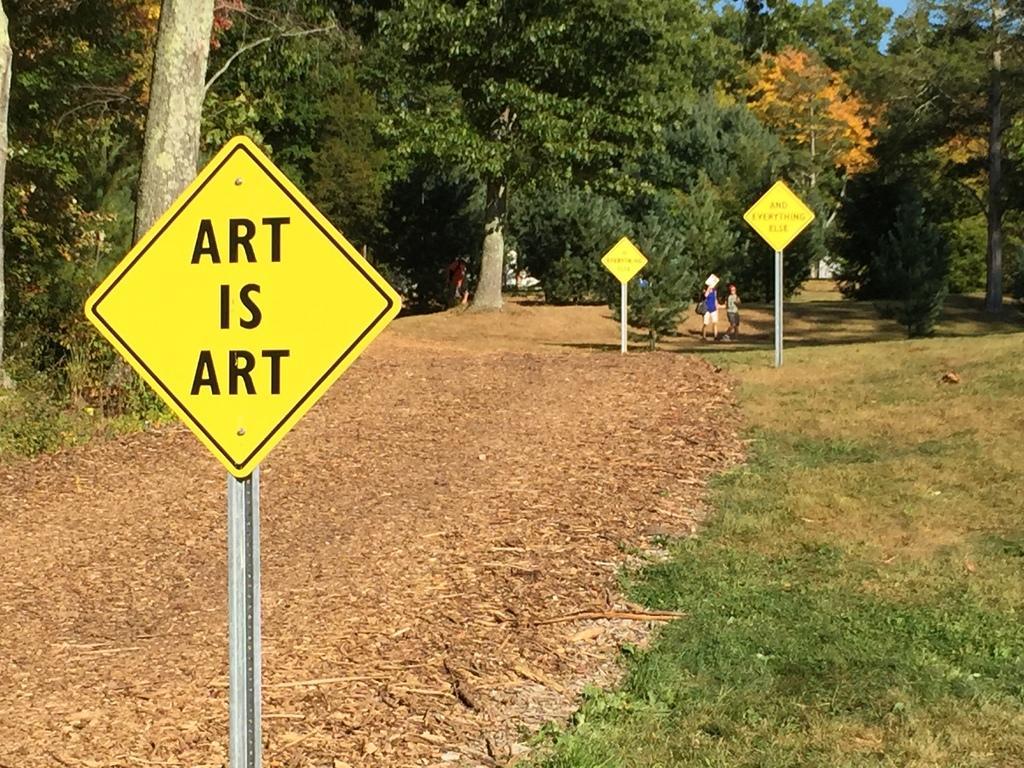Could you give a brief overview of what you see in this image? In this image in front there are boards and we can see grass on the surface. On the backside there are two persons on the surface of the grass. In the background there are trees and sky. 